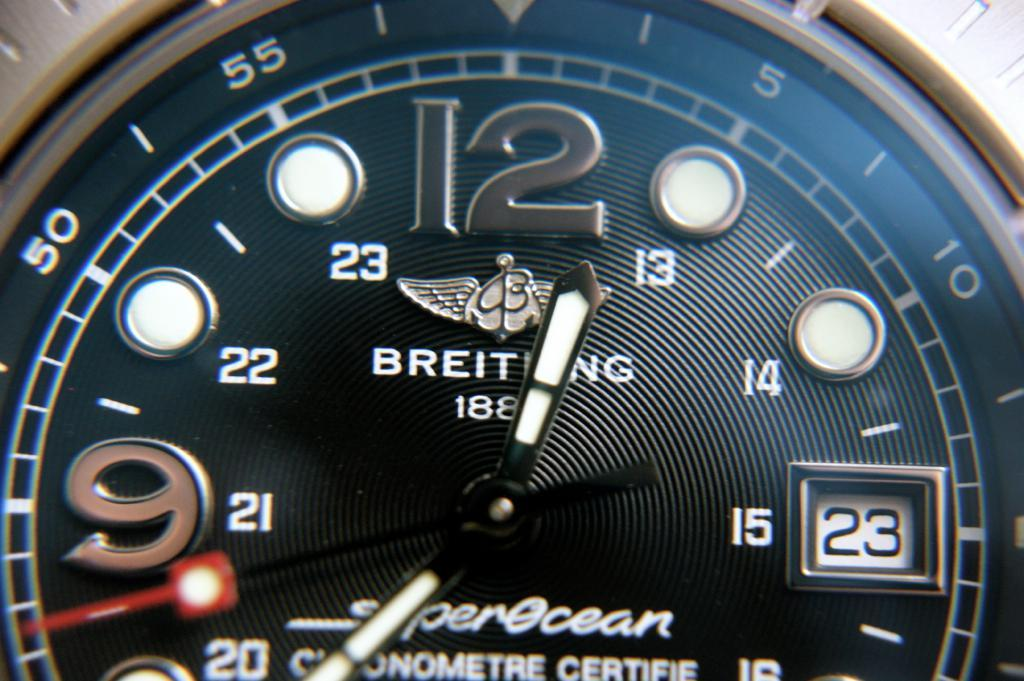<image>
Write a terse but informative summary of the picture. Fancy watch from the company Breiting showing the time. 